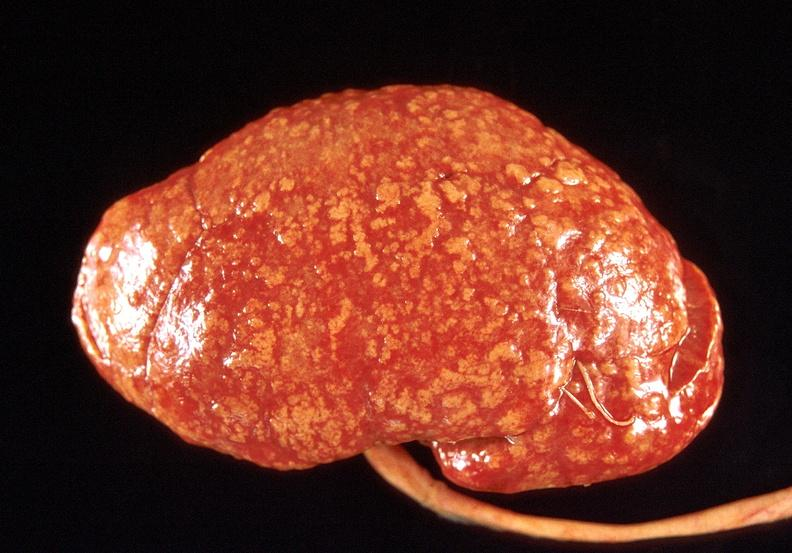does thermal show kidney, obliterative endarteritis - sclerodema?
Answer the question using a single word or phrase. No 